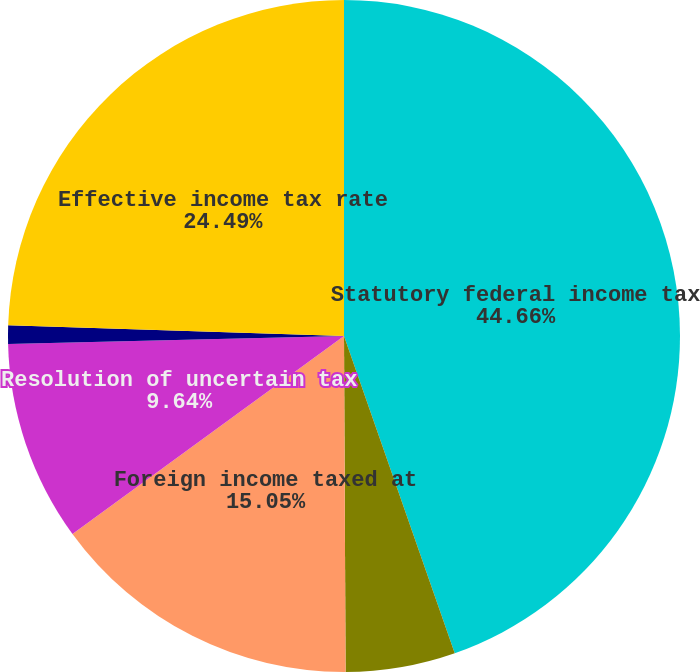Convert chart. <chart><loc_0><loc_0><loc_500><loc_500><pie_chart><fcel>Statutory federal income tax<fcel>State income taxes (net of<fcel>Foreign income taxed at<fcel>Resolution of uncertain tax<fcel>Research and experimentation<fcel>Effective income tax rate<nl><fcel>44.65%<fcel>5.27%<fcel>15.05%<fcel>9.64%<fcel>0.89%<fcel>24.49%<nl></chart> 